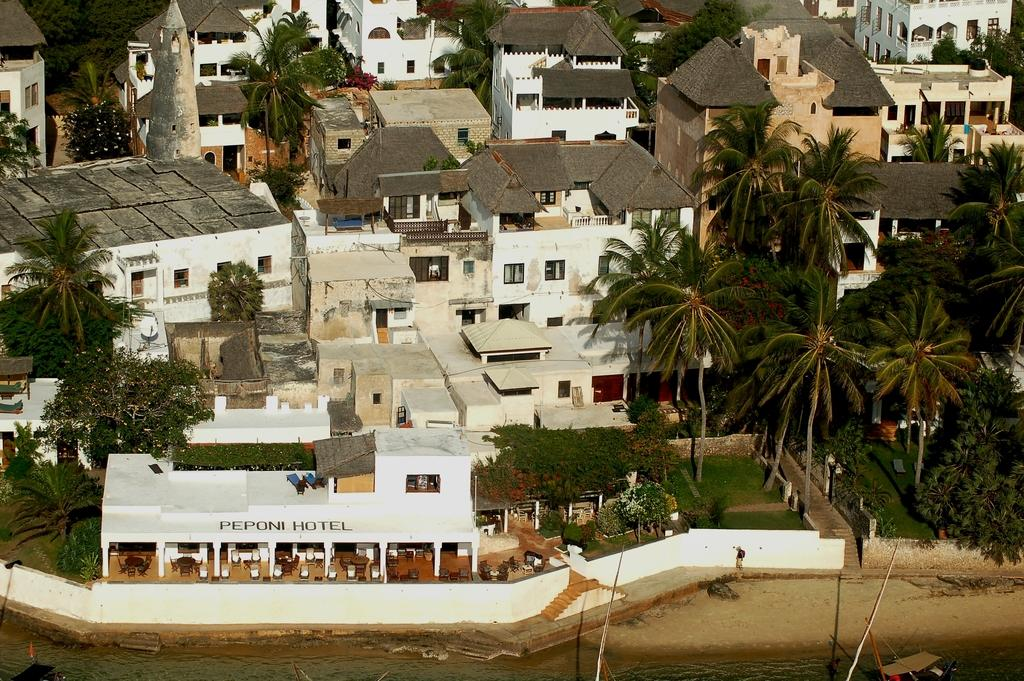What type of building is the main subject in the image? There is a hotel in the image. What natural elements can be seen in the image? There are many trees and green grass in the image. What type of residential structures are visible in the background? There are many houses in the background of the image. What color is the curtain hanging in the hotel room in the image? There is no curtain visible in the image; it only shows the exterior of the hotel. Can you spot any bees buzzing around the trees in the image? There are no bees present in the image; it only shows the hotel, trees, and grass. 